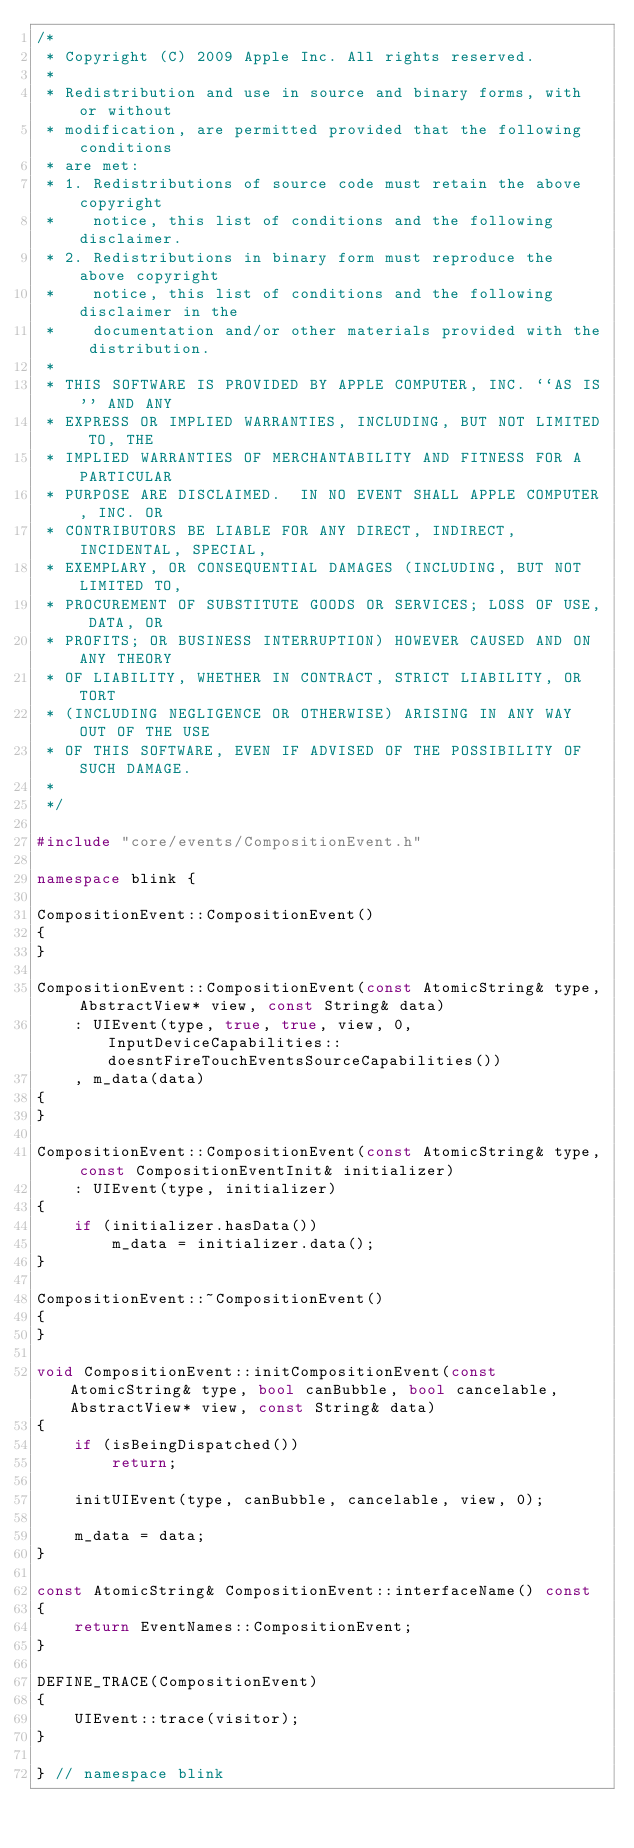<code> <loc_0><loc_0><loc_500><loc_500><_C++_>/*
 * Copyright (C) 2009 Apple Inc. All rights reserved.
 *
 * Redistribution and use in source and binary forms, with or without
 * modification, are permitted provided that the following conditions
 * are met:
 * 1. Redistributions of source code must retain the above copyright
 *    notice, this list of conditions and the following disclaimer.
 * 2. Redistributions in binary form must reproduce the above copyright
 *    notice, this list of conditions and the following disclaimer in the
 *    documentation and/or other materials provided with the distribution.
 *
 * THIS SOFTWARE IS PROVIDED BY APPLE COMPUTER, INC. ``AS IS'' AND ANY
 * EXPRESS OR IMPLIED WARRANTIES, INCLUDING, BUT NOT LIMITED TO, THE
 * IMPLIED WARRANTIES OF MERCHANTABILITY AND FITNESS FOR A PARTICULAR
 * PURPOSE ARE DISCLAIMED.  IN NO EVENT SHALL APPLE COMPUTER, INC. OR
 * CONTRIBUTORS BE LIABLE FOR ANY DIRECT, INDIRECT, INCIDENTAL, SPECIAL,
 * EXEMPLARY, OR CONSEQUENTIAL DAMAGES (INCLUDING, BUT NOT LIMITED TO,
 * PROCUREMENT OF SUBSTITUTE GOODS OR SERVICES; LOSS OF USE, DATA, OR
 * PROFITS; OR BUSINESS INTERRUPTION) HOWEVER CAUSED AND ON ANY THEORY
 * OF LIABILITY, WHETHER IN CONTRACT, STRICT LIABILITY, OR TORT
 * (INCLUDING NEGLIGENCE OR OTHERWISE) ARISING IN ANY WAY OUT OF THE USE
 * OF THIS SOFTWARE, EVEN IF ADVISED OF THE POSSIBILITY OF SUCH DAMAGE.
 *
 */

#include "core/events/CompositionEvent.h"

namespace blink {

CompositionEvent::CompositionEvent()
{
}

CompositionEvent::CompositionEvent(const AtomicString& type, AbstractView* view, const String& data)
    : UIEvent(type, true, true, view, 0, InputDeviceCapabilities::doesntFireTouchEventsSourceCapabilities())
    , m_data(data)
{
}

CompositionEvent::CompositionEvent(const AtomicString& type, const CompositionEventInit& initializer)
    : UIEvent(type, initializer)
{
    if (initializer.hasData())
        m_data = initializer.data();
}

CompositionEvent::~CompositionEvent()
{
}

void CompositionEvent::initCompositionEvent(const AtomicString& type, bool canBubble, bool cancelable, AbstractView* view, const String& data)
{
    if (isBeingDispatched())
        return;

    initUIEvent(type, canBubble, cancelable, view, 0);

    m_data = data;
}

const AtomicString& CompositionEvent::interfaceName() const
{
    return EventNames::CompositionEvent;
}

DEFINE_TRACE(CompositionEvent)
{
    UIEvent::trace(visitor);
}

} // namespace blink
</code> 